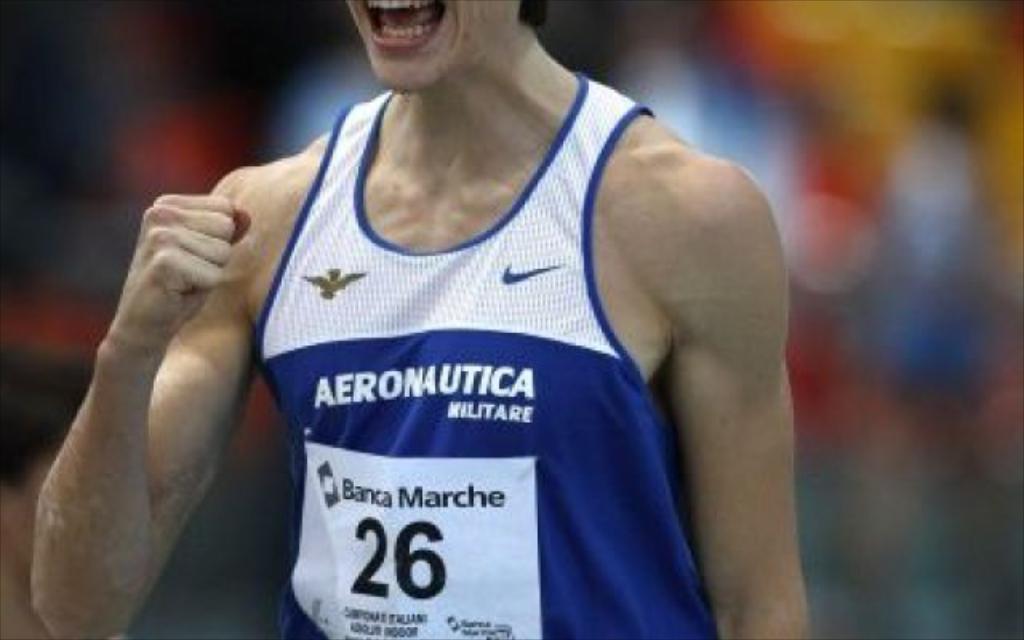Who is the sponsor on the front of the jersey?
Keep it short and to the point. Aeronautica. What number is on the players shirt?
Give a very brief answer. 26. 